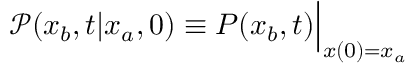Convert formula to latex. <formula><loc_0><loc_0><loc_500><loc_500>\mathcal { P } ( x _ { b } , t | x _ { a } , 0 ) \equiv P ( x _ { b } , t ) \Big | _ { x ( 0 ) = x _ { a } }</formula> 